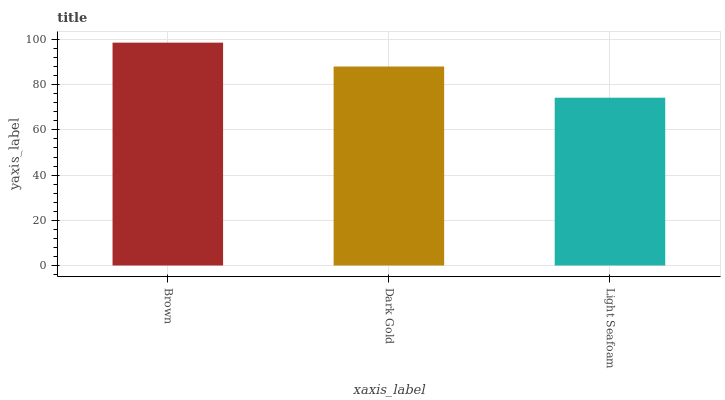Is Light Seafoam the minimum?
Answer yes or no. Yes. Is Brown the maximum?
Answer yes or no. Yes. Is Dark Gold the minimum?
Answer yes or no. No. Is Dark Gold the maximum?
Answer yes or no. No. Is Brown greater than Dark Gold?
Answer yes or no. Yes. Is Dark Gold less than Brown?
Answer yes or no. Yes. Is Dark Gold greater than Brown?
Answer yes or no. No. Is Brown less than Dark Gold?
Answer yes or no. No. Is Dark Gold the high median?
Answer yes or no. Yes. Is Dark Gold the low median?
Answer yes or no. Yes. Is Brown the high median?
Answer yes or no. No. Is Light Seafoam the low median?
Answer yes or no. No. 